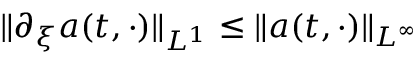<formula> <loc_0><loc_0><loc_500><loc_500>\| \partial _ { \xi } a ( t , \cdot ) \| _ { L ^ { 1 } } \leq \| a ( t , \cdot ) \| _ { L ^ { \infty } }</formula> 